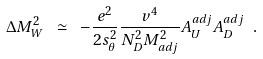<formula> <loc_0><loc_0><loc_500><loc_500>\Delta M _ { W } ^ { 2 } \ \simeq \ - { \frac { e ^ { 2 } } { 2 s _ { \theta } ^ { 2 } } } { \frac { v ^ { 4 } } { N _ { D } ^ { 2 } M _ { a d j } ^ { 2 } } } A _ { U } ^ { a d j } A _ { D } ^ { a d j } \ .</formula> 